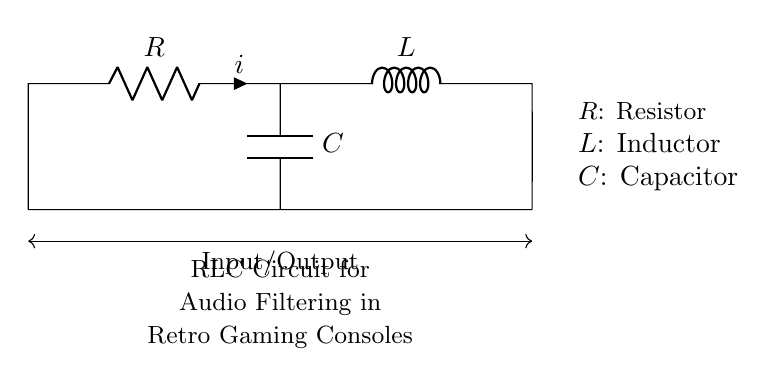What types of components are used in this circuit? The circuit consists of a Resistor, an Inductor, and a Capacitor, indicated by R, L, and C respectively.
Answer: Resistor, Inductor, Capacitor What is the purpose of this RLC circuit? The labeled text at the bottom of the circuit diagram states that it is for audio filtering in retro gaming consoles.
Answer: Audio filtering Which component is connected in parallel to the capacitor? The diagram shows that the capacitor (C) is connected in parallel with the points where the resistor (R) and inductor (L) are connected. Thus, nothing is directly in parallel to it; only the rest of the circuit is.
Answer: None How many nodes are present in this circuit? By looking at the circuit's layout, there are four distinct connection points (nodes) formed where components connect: one at the top of R, one at the end of L, and two at the ends of C.
Answer: Four What type of circuit is this? The presence of a resistor, inductor, and capacitor in a configuration used for filtering indicates this is an RLC circuit.
Answer: RLC circuit What does the current through the resistor (i) indicate in this circuit? The label on the circuit diagram indicates the current flowing through the resistor, denoted as 'i', which implies it's the same current flowing through the series components in this configuration.
Answer: Current 'i' 